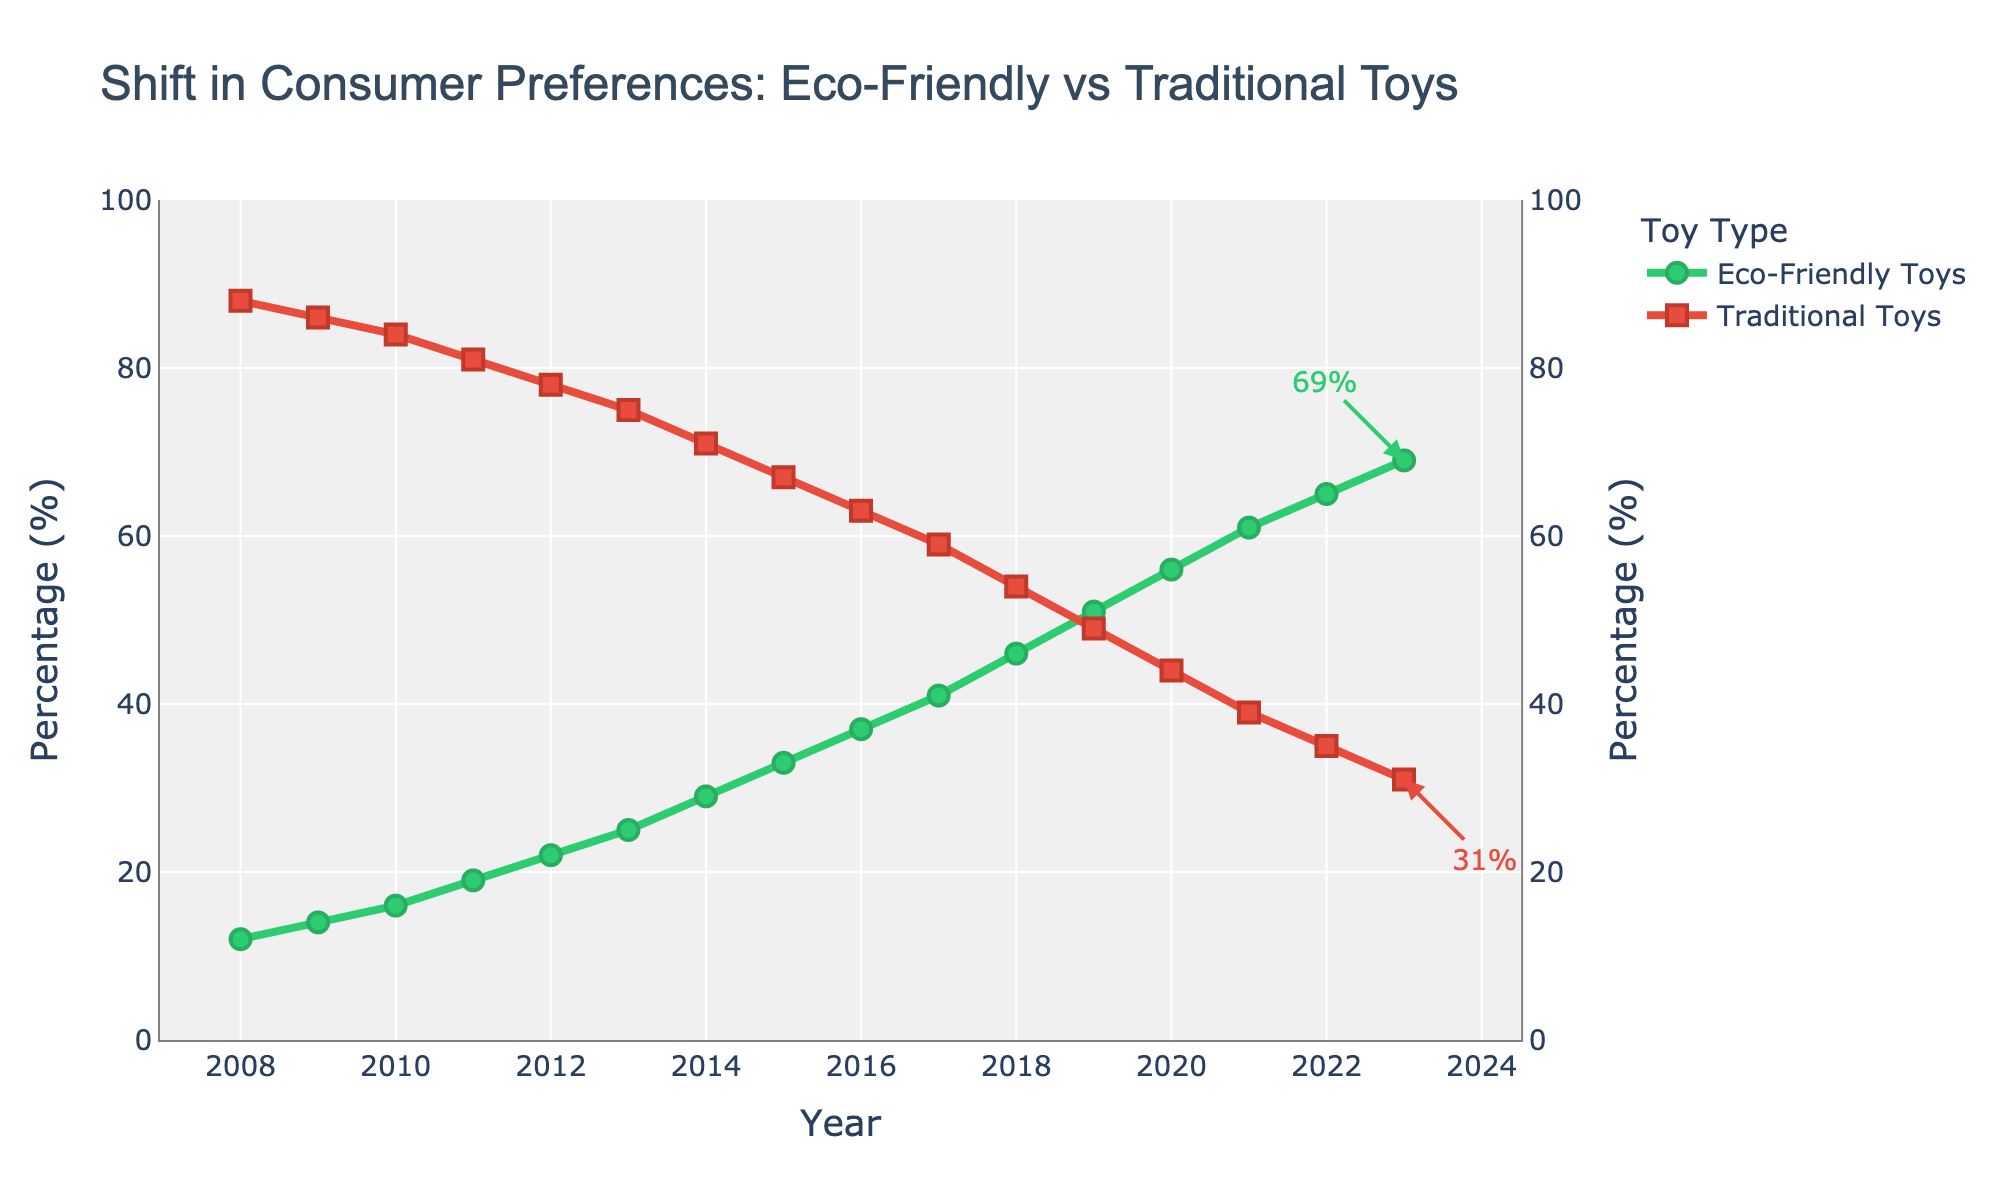What was the percentage of eco-friendly toys in 2015? Look for the year 2015 on the x-axis and find the corresponding point for eco-friendly toys on the y-axis, which is marked with a green circle.
Answer: 33% Which type of toy had a higher percentage in 2012, and by how much? Locate the year 2012 on the x-axis and compare the percentages of eco-friendly toys (22%) and traditional toys (78%). Calculate the difference: 78% - 22%.
Answer: Traditional toys, by 56% What is the overall trend for eco-friendly toys from 2008 to 2023? Observe the green trendline for eco-friendly toys from 2008 to 2023. The line shows an upward trajectory indicating an increase in percentage over time.
Answer: Increasing In which year did eco-friendly toys reach a 50% market share? Look for the point where the green line reaches 50% on the y-axis. This happens in the year 2019.
Answer: 2019 How much did the market share of traditional toys decrease from 2008 to 2023? Find the percentages of traditional toys for 2008 (88%) and 2023 (31%). Calculate the decrease: 88% - 31%.
Answer: 57% What is the average market share of eco-friendly toys from 2008 to 2023? Sum the percentages of eco-friendly toys from 2008 to 2023 and divide by the number of years (16). (12 + 14 + 16 + 19 + 22 + 25 + 29 + 33 + 37 + 41 + 46 + 51 + 56 + 61 + 65 + 69) / 16.
Answer: 36.875% During which year did the market share of eco-friendly toys surpass traditional toys? Find the year where the green line (eco-friendly) intersects and starts to climb above the red line (traditional). This happens in 2018.
Answer: 2018 What is the difference between the percentages of traditional toys in the years 2017 and 2022? Locate the percentages for traditional toys in 2017 (59%) and 2022 (35%). Calculate the difference: 59% - 35%.
Answer: 24% Compare the rate of increase in the market share of eco-friendly toys between the periods 2008-2011 and 2020-2023. Which period shows a faster increase? Calculate the change in percentage over each period: 2008-2011 (19% - 12%) = 7%, and 2020-2023 (69% - 56%) = 13%. The rate of increase is greater in the 2020-2023 period.
Answer: 2020-2023 What visual cues indicate the increasing popularity of eco-friendly toys over the years? Observe the upward trend of the green line for eco-friendly toys and the year markers along the x-axis. Additionally, note the annotations highlighting the latest percentage values making it visually clear.
Answer: Upward trend, green line, annotations 